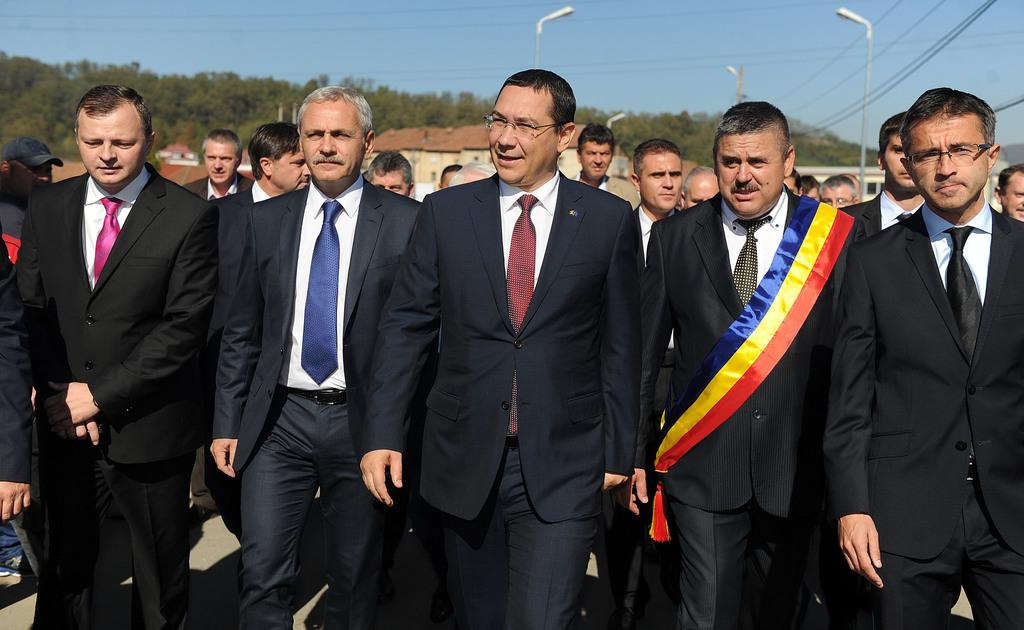How many people are in the image? There are people in the image, but the exact number is not specified. What is unique about the man's attire in the image? There is a man wearing a sash in the image. What can be seen in the background of the image? In the background of the image, there are light poles, wires, houses, trees, and the sky. What type of bell can be heard ringing in the image? There is no bell present or ringing in the image. How many beds are visible in the image? There is no mention of beds in the image, so it is impossible to determine their number. 